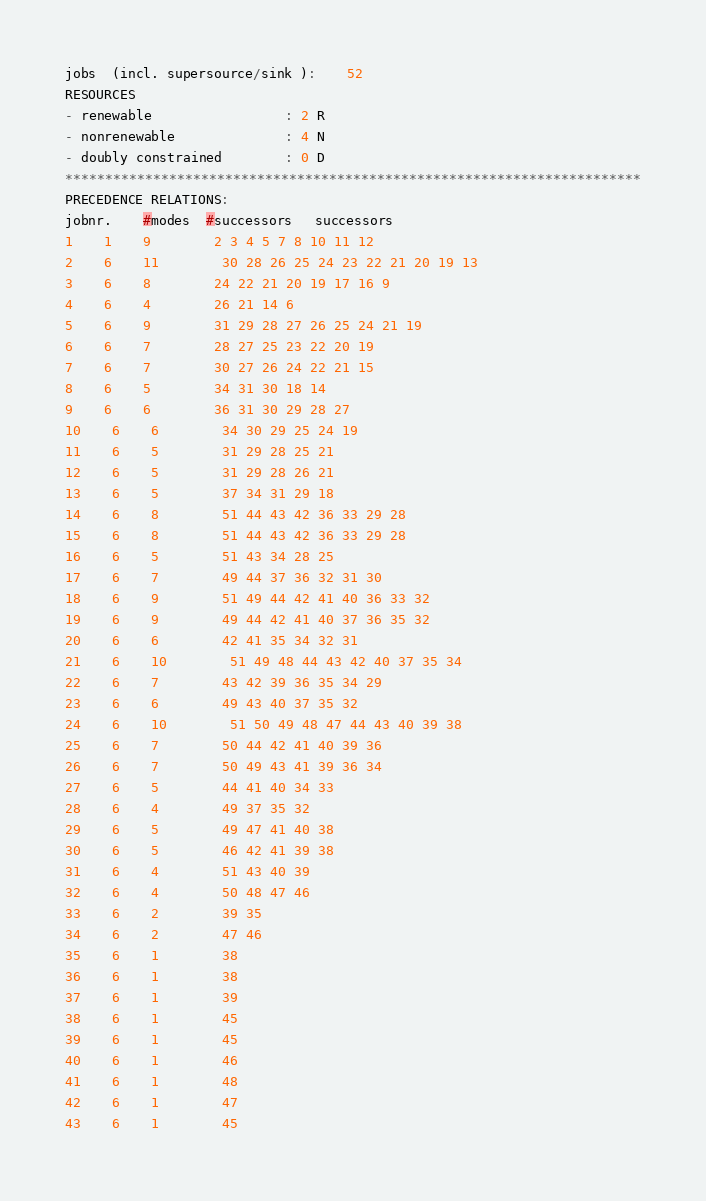<code> <loc_0><loc_0><loc_500><loc_500><_ObjectiveC_>jobs  (incl. supersource/sink ):	52
RESOURCES
- renewable                 : 2 R
- nonrenewable              : 4 N
- doubly constrained        : 0 D
************************************************************************
PRECEDENCE RELATIONS:
jobnr.    #modes  #successors   successors
1	1	9		2 3 4 5 7 8 10 11 12 
2	6	11		30 28 26 25 24 23 22 21 20 19 13 
3	6	8		24 22 21 20 19 17 16 9 
4	6	4		26 21 14 6 
5	6	9		31 29 28 27 26 25 24 21 19 
6	6	7		28 27 25 23 22 20 19 
7	6	7		30 27 26 24 22 21 15 
8	6	5		34 31 30 18 14 
9	6	6		36 31 30 29 28 27 
10	6	6		34 30 29 25 24 19 
11	6	5		31 29 28 25 21 
12	6	5		31 29 28 26 21 
13	6	5		37 34 31 29 18 
14	6	8		51 44 43 42 36 33 29 28 
15	6	8		51 44 43 42 36 33 29 28 
16	6	5		51 43 34 28 25 
17	6	7		49 44 37 36 32 31 30 
18	6	9		51 49 44 42 41 40 36 33 32 
19	6	9		49 44 42 41 40 37 36 35 32 
20	6	6		42 41 35 34 32 31 
21	6	10		51 49 48 44 43 42 40 37 35 34 
22	6	7		43 42 39 36 35 34 29 
23	6	6		49 43 40 37 35 32 
24	6	10		51 50 49 48 47 44 43 40 39 38 
25	6	7		50 44 42 41 40 39 36 
26	6	7		50 49 43 41 39 36 34 
27	6	5		44 41 40 34 33 
28	6	4		49 37 35 32 
29	6	5		49 47 41 40 38 
30	6	5		46 42 41 39 38 
31	6	4		51 43 40 39 
32	6	4		50 48 47 46 
33	6	2		39 35 
34	6	2		47 46 
35	6	1		38 
36	6	1		38 
37	6	1		39 
38	6	1		45 
39	6	1		45 
40	6	1		46 
41	6	1		48 
42	6	1		47 
43	6	1		45 </code> 